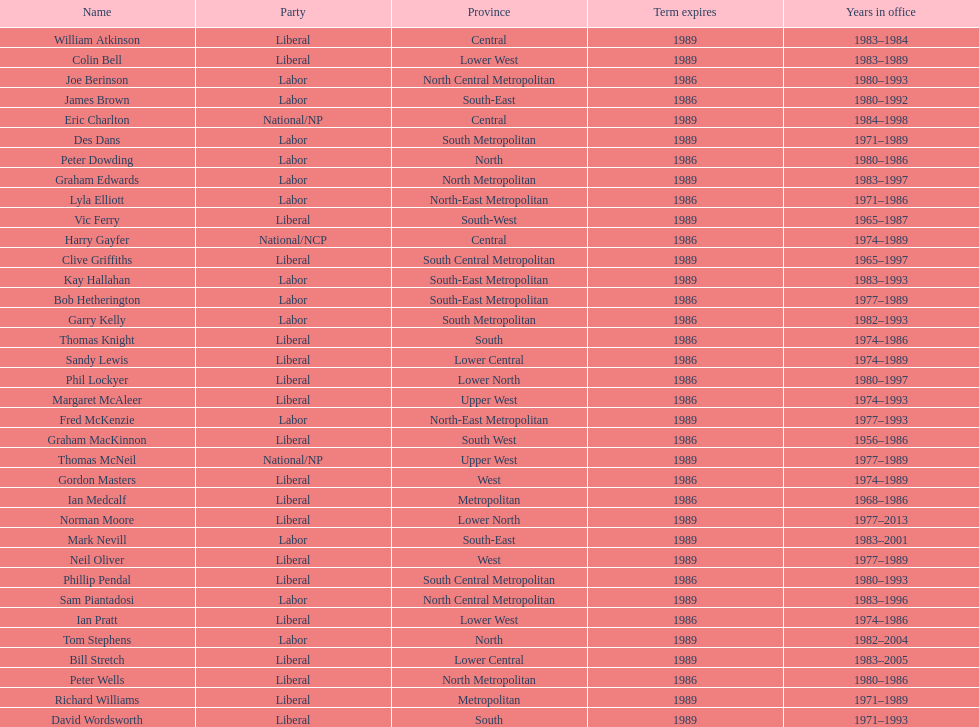What is the cumulative number of members with terms ending in 1989? 9. 